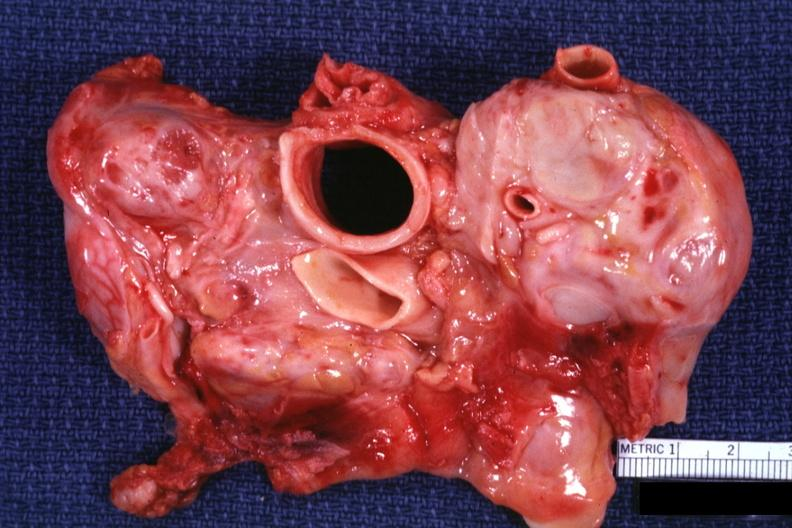s lymph node present?
Answer the question using a single word or phrase. Yes 